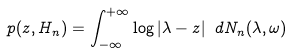<formula> <loc_0><loc_0><loc_500><loc_500>p ( z , H _ { n } ) = \int _ { - \infty } ^ { + \infty } \log | \lambda - z | \ d N _ { n } ( \lambda , \omega )</formula> 